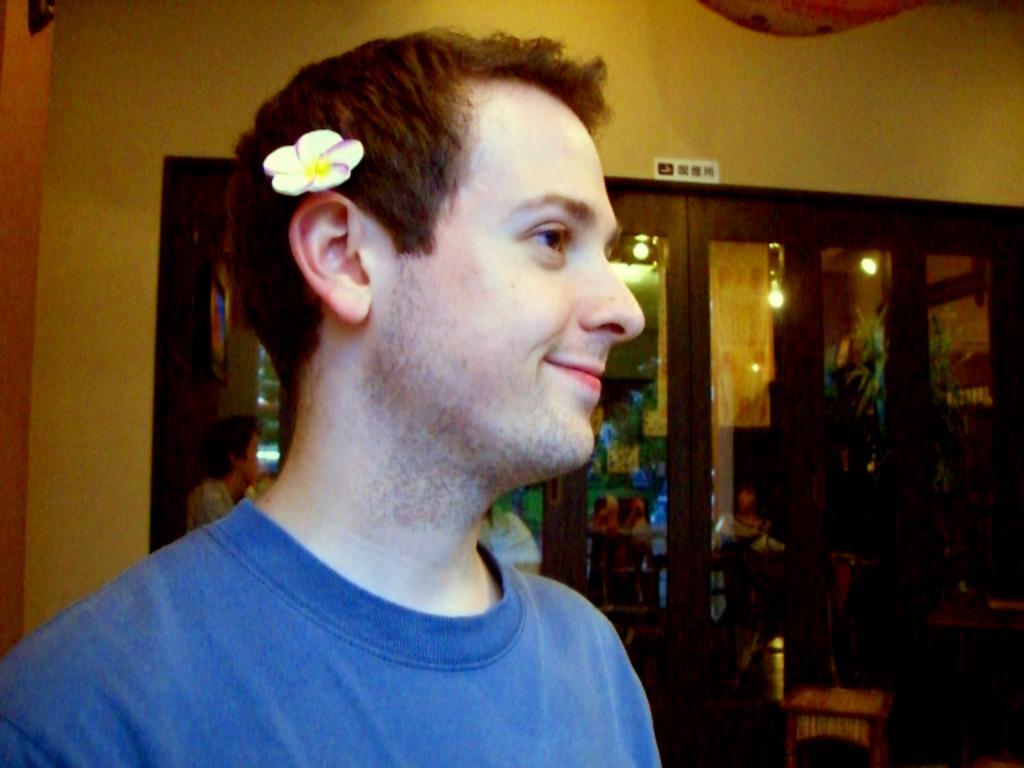How would you summarize this image in a sentence or two? In this image we can see a man smiling and there is a flower behind the ear and in the background, we can see the glass object and we can see the reflection of few people and some other objects. 